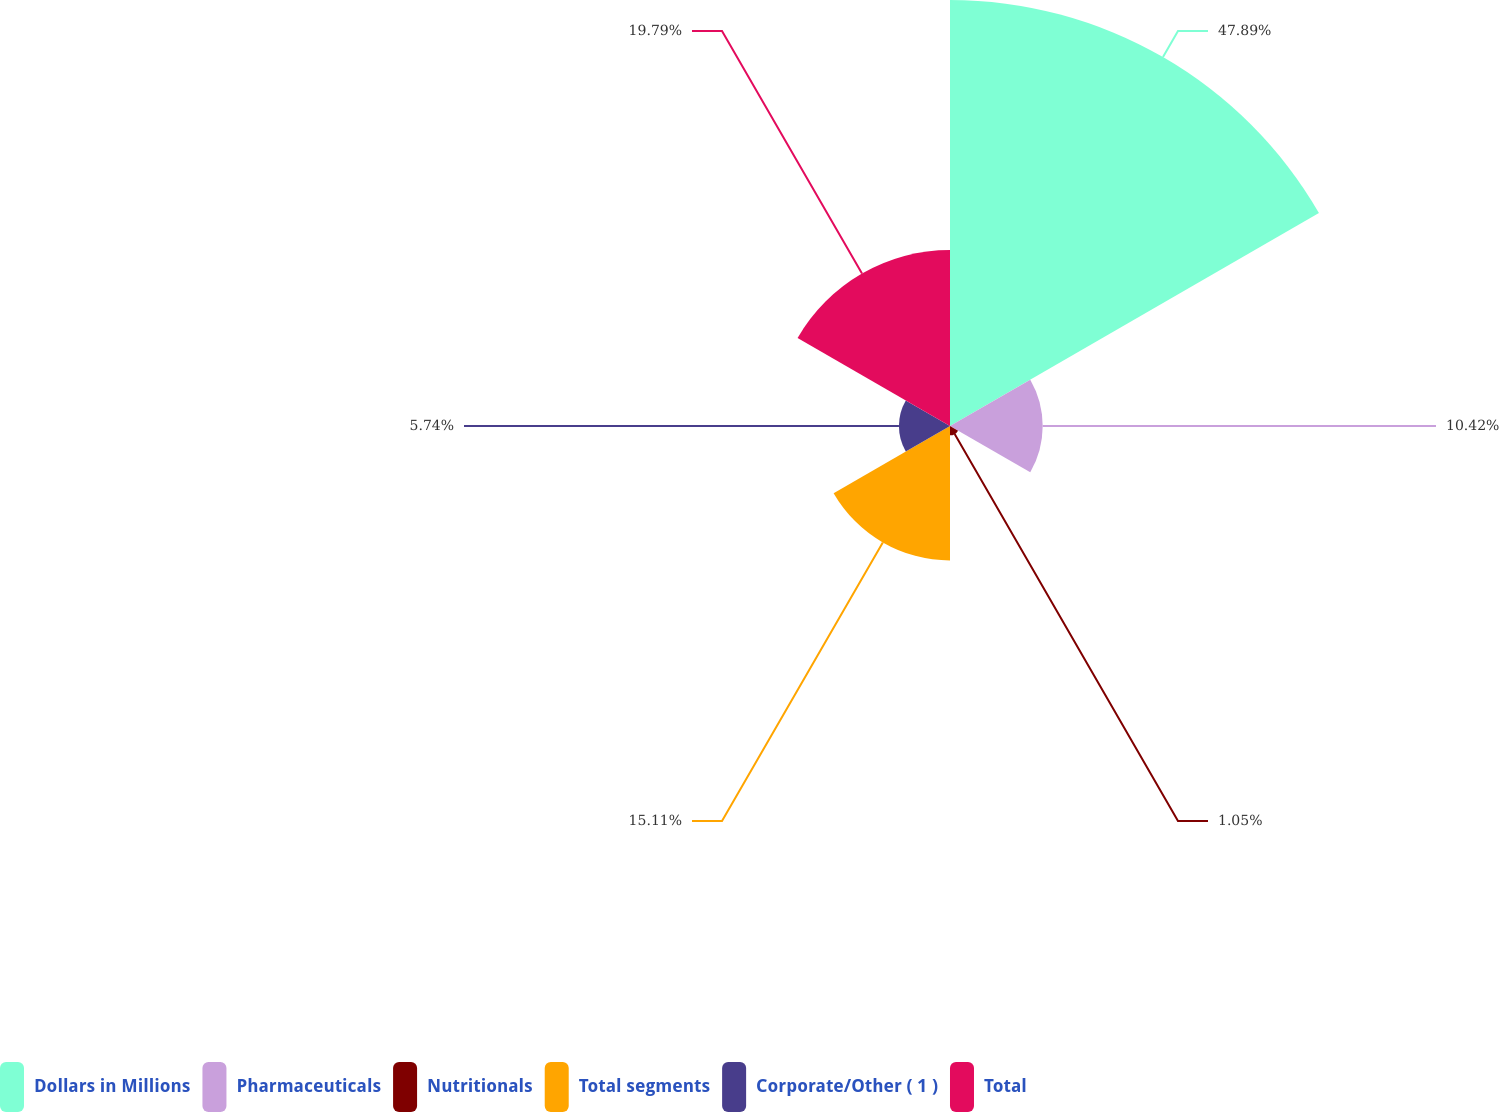Convert chart to OTSL. <chart><loc_0><loc_0><loc_500><loc_500><pie_chart><fcel>Dollars in Millions<fcel>Pharmaceuticals<fcel>Nutritionals<fcel>Total segments<fcel>Corporate/Other ( 1 )<fcel>Total<nl><fcel>47.9%<fcel>10.42%<fcel>1.05%<fcel>15.11%<fcel>5.74%<fcel>19.79%<nl></chart> 